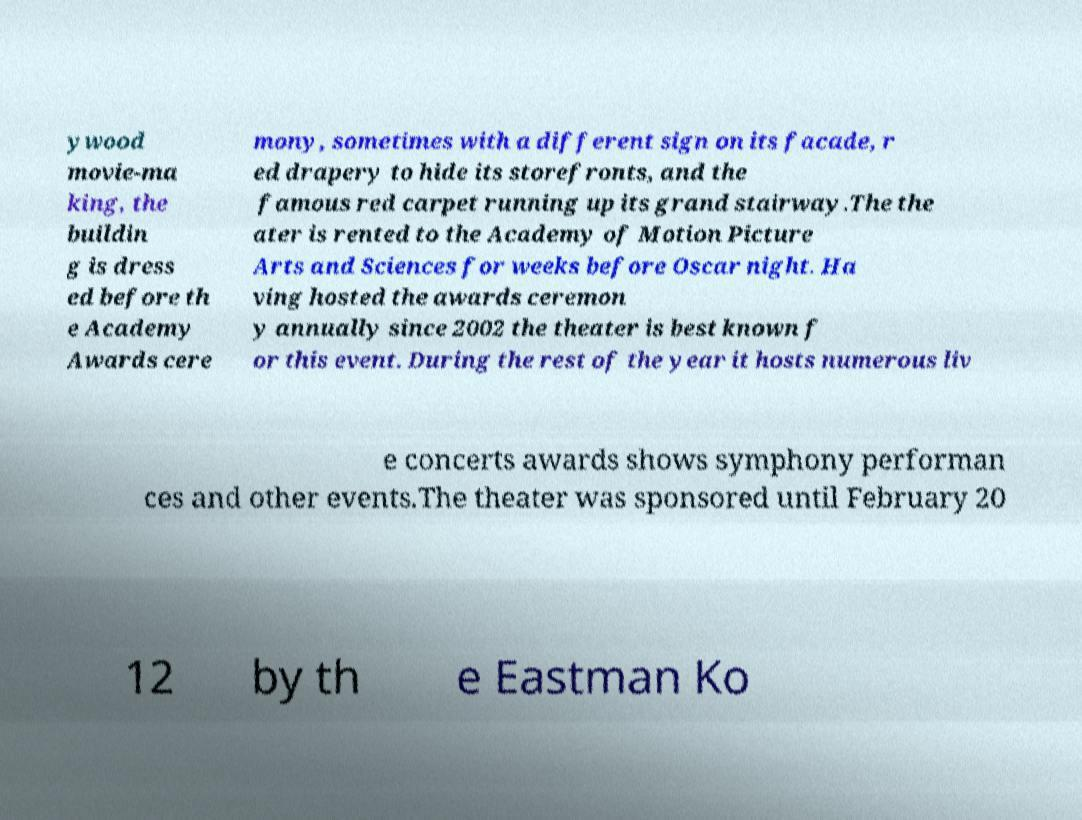Can you accurately transcribe the text from the provided image for me? ywood movie-ma king, the buildin g is dress ed before th e Academy Awards cere mony, sometimes with a different sign on its facade, r ed drapery to hide its storefronts, and the famous red carpet running up its grand stairway.The the ater is rented to the Academy of Motion Picture Arts and Sciences for weeks before Oscar night. Ha ving hosted the awards ceremon y annually since 2002 the theater is best known f or this event. During the rest of the year it hosts numerous liv e concerts awards shows symphony performan ces and other events.The theater was sponsored until February 20 12 by th e Eastman Ko 